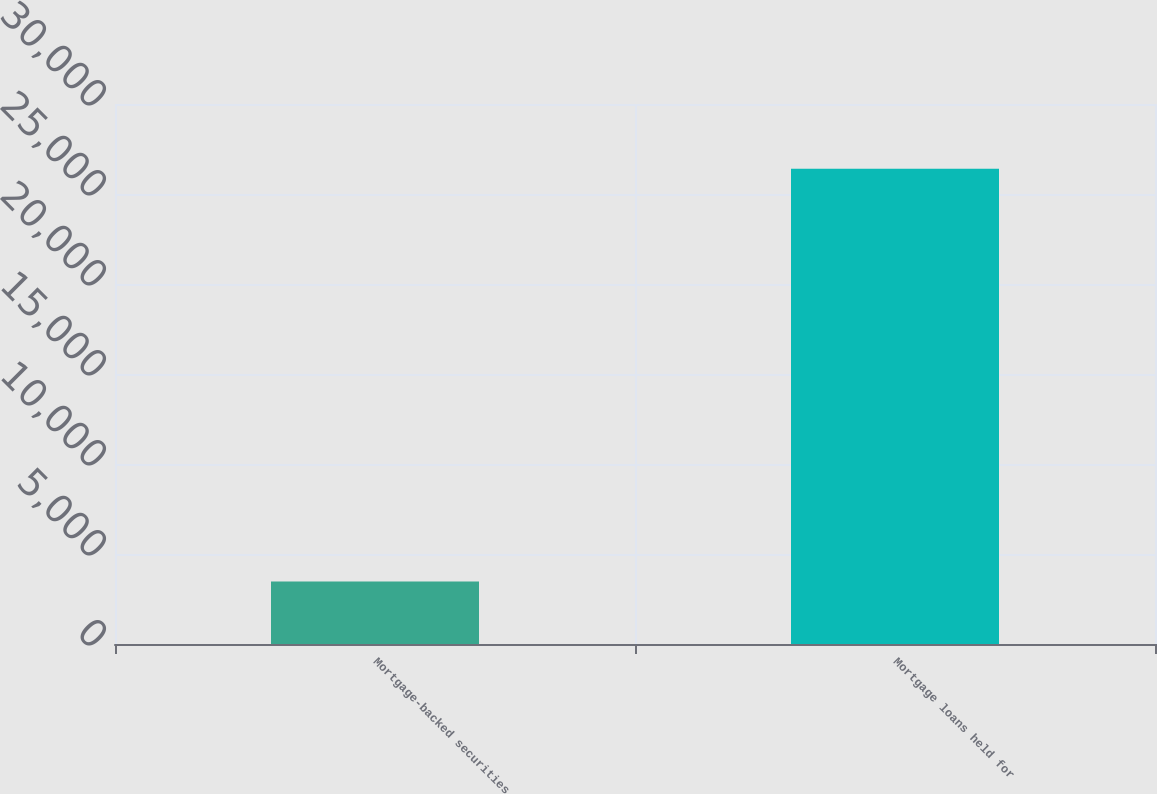Convert chart to OTSL. <chart><loc_0><loc_0><loc_500><loc_500><bar_chart><fcel>Mortgage-backed securities<fcel>Mortgage loans held for<nl><fcel>3472<fcel>26403<nl></chart> 